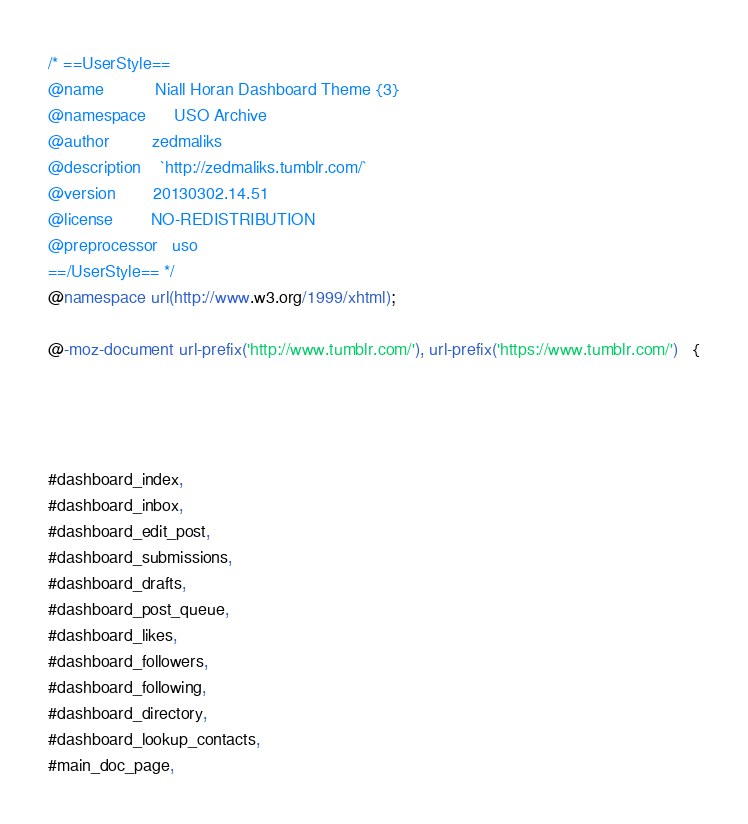<code> <loc_0><loc_0><loc_500><loc_500><_CSS_>/* ==UserStyle==
@name           Niall Horan Dashboard Theme {3}
@namespace      USO Archive
@author         zedmaliks
@description    `http://zedmaliks.tumblr.com/`
@version        20130302.14.51
@license        NO-REDISTRIBUTION
@preprocessor   uso
==/UserStyle== */
@namespace url(http://www.w3.org/1999/xhtml);

@-moz-document url-prefix('http://www.tumblr.com/'), url-prefix('https://www.tumblr.com/')   {




#dashboard_index,
#dashboard_inbox,
#dashboard_edit_post,
#dashboard_submissions,
#dashboard_drafts,
#dashboard_post_queue,
#dashboard_likes,
#dashboard_followers,
#dashboard_following,
#dashboard_directory,
#dashboard_lookup_contacts,
#main_doc_page,</code> 